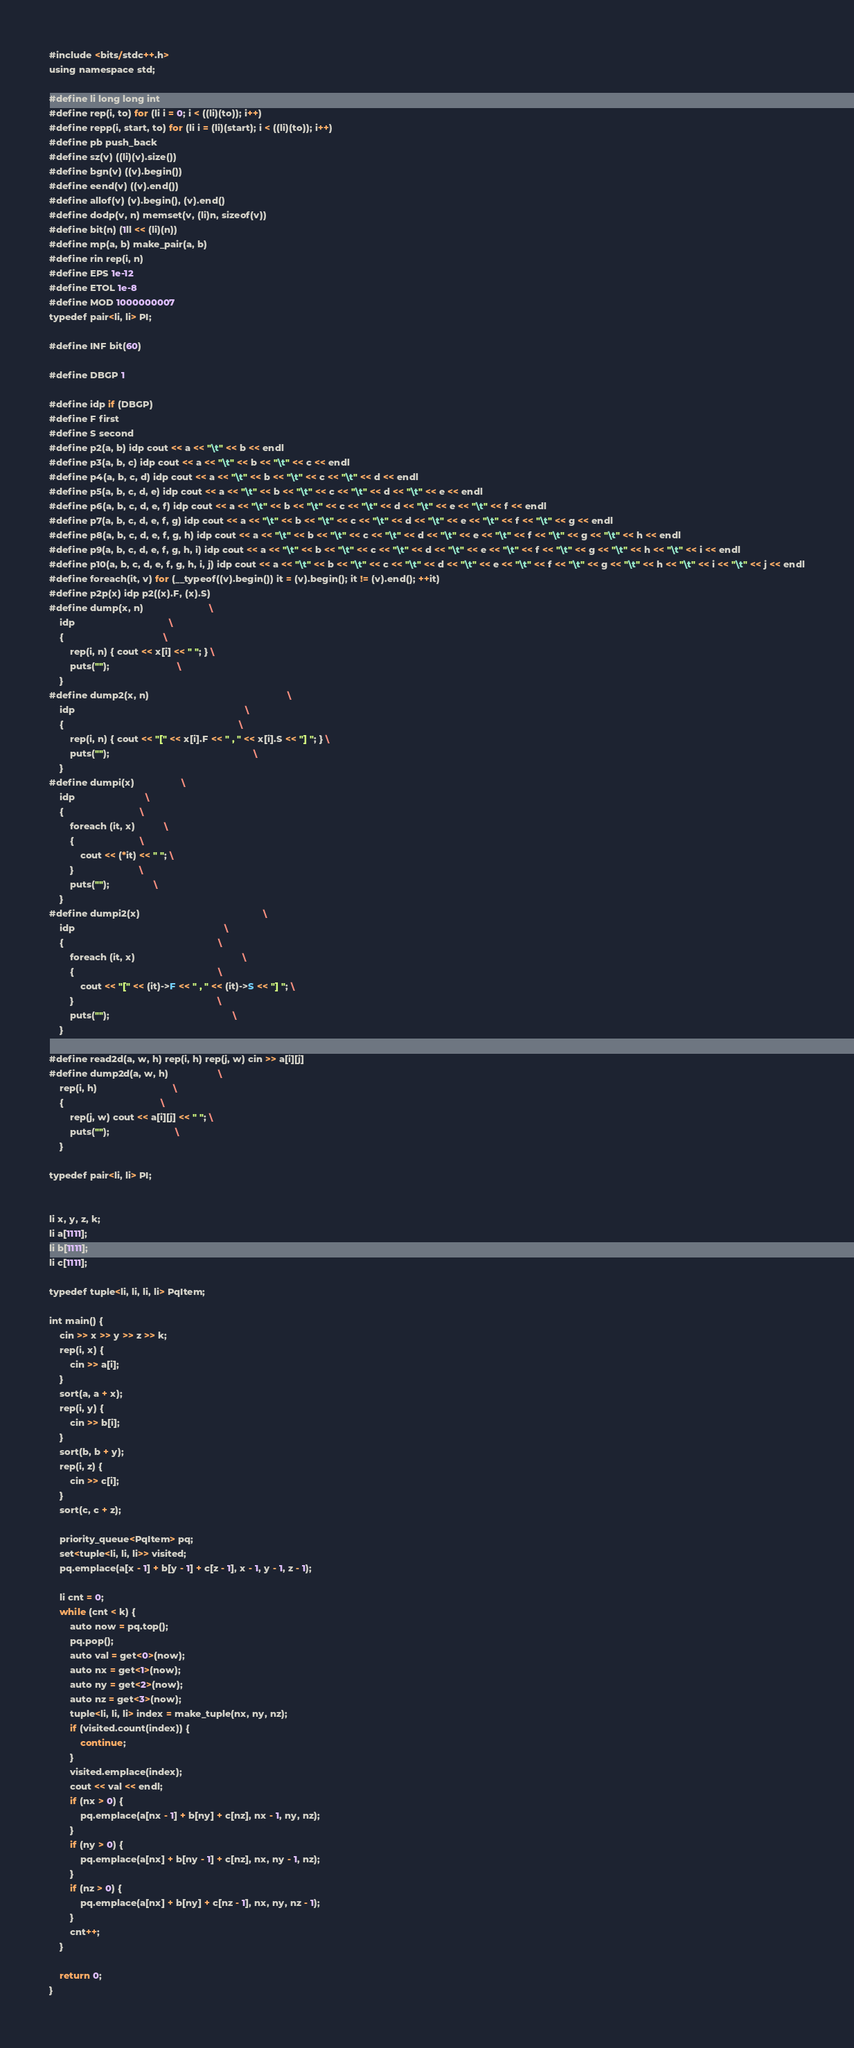<code> <loc_0><loc_0><loc_500><loc_500><_Rust_>#include <bits/stdc++.h>
using namespace std;

#define li long long int
#define rep(i, to) for (li i = 0; i < ((li)(to)); i++)
#define repp(i, start, to) for (li i = (li)(start); i < ((li)(to)); i++)
#define pb push_back
#define sz(v) ((li)(v).size())
#define bgn(v) ((v).begin())
#define eend(v) ((v).end())
#define allof(v) (v).begin(), (v).end()
#define dodp(v, n) memset(v, (li)n, sizeof(v))
#define bit(n) (1ll << (li)(n))
#define mp(a, b) make_pair(a, b)
#define rin rep(i, n)
#define EPS 1e-12
#define ETOL 1e-8
#define MOD 1000000007
typedef pair<li, li> PI;

#define INF bit(60)

#define DBGP 1

#define idp if (DBGP)
#define F first
#define S second
#define p2(a, b) idp cout << a << "\t" << b << endl
#define p3(a, b, c) idp cout << a << "\t" << b << "\t" << c << endl
#define p4(a, b, c, d) idp cout << a << "\t" << b << "\t" << c << "\t" << d << endl
#define p5(a, b, c, d, e) idp cout << a << "\t" << b << "\t" << c << "\t" << d << "\t" << e << endl
#define p6(a, b, c, d, e, f) idp cout << a << "\t" << b << "\t" << c << "\t" << d << "\t" << e << "\t" << f << endl
#define p7(a, b, c, d, e, f, g) idp cout << a << "\t" << b << "\t" << c << "\t" << d << "\t" << e << "\t" << f << "\t" << g << endl
#define p8(a, b, c, d, e, f, g, h) idp cout << a << "\t" << b << "\t" << c << "\t" << d << "\t" << e << "\t" << f << "\t" << g << "\t" << h << endl
#define p9(a, b, c, d, e, f, g, h, i) idp cout << a << "\t" << b << "\t" << c << "\t" << d << "\t" << e << "\t" << f << "\t" << g << "\t" << h << "\t" << i << endl
#define p10(a, b, c, d, e, f, g, h, i, j) idp cout << a << "\t" << b << "\t" << c << "\t" << d << "\t" << e << "\t" << f << "\t" << g << "\t" << h << "\t" << i << "\t" << j << endl
#define foreach(it, v) for (__typeof((v).begin()) it = (v).begin(); it != (v).end(); ++it)
#define p2p(x) idp p2((x).F, (x).S)
#define dump(x, n)                         \
    idp                                    \
    {                                      \
        rep(i, n) { cout << x[i] << " "; } \
        puts("");                          \
    }
#define dump2(x, n)                                                     \
    idp                                                                 \
    {                                                                   \
        rep(i, n) { cout << "[" << x[i].F << " , " << x[i].S << "] "; } \
        puts("");                                                       \
    }
#define dumpi(x)                  \
    idp                           \
    {                             \
        foreach (it, x)           \
        {                         \
            cout << (*it) << " "; \
        }                         \
        puts("");                 \
    }
#define dumpi2(x)                                               \
    idp                                                         \
    {                                                           \
        foreach (it, x)                                         \
        {                                                       \
            cout << "[" << (it)->F << " , " << (it)->S << "] "; \
        }                                                       \
        puts("");                                               \
    }

#define read2d(a, w, h) rep(i, h) rep(j, w) cin >> a[i][j]
#define dump2d(a, w, h)                   \
    rep(i, h)                             \
    {                                     \
        rep(j, w) cout << a[i][j] << " "; \
        puts("");                         \
    }

typedef pair<li, li> PI;


li x, y, z, k;
li a[1111];
li b[1111];
li c[1111];

typedef tuple<li, li, li, li> PqItem;

int main() {
    cin >> x >> y >> z >> k;
    rep(i, x) {
        cin >> a[i];
    }
    sort(a, a + x);
    rep(i, y) {
        cin >> b[i];
    }
    sort(b, b + y);
    rep(i, z) {
        cin >> c[i];
    }
    sort(c, c + z);

    priority_queue<PqItem> pq;
    set<tuple<li, li, li>> visited;
    pq.emplace(a[x - 1] + b[y - 1] + c[z - 1], x - 1, y - 1, z - 1);

    li cnt = 0;
    while (cnt < k) {
        auto now = pq.top();
        pq.pop();
        auto val = get<0>(now);
        auto nx = get<1>(now);
        auto ny = get<2>(now);
        auto nz = get<3>(now);
        tuple<li, li, li> index = make_tuple(nx, ny, nz);
        if (visited.count(index)) {
            continue;
        }
        visited.emplace(index);
        cout << val << endl;
        if (nx > 0) {
            pq.emplace(a[nx - 1] + b[ny] + c[nz], nx - 1, ny, nz);
        }
        if (ny > 0) {
            pq.emplace(a[nx] + b[ny - 1] + c[nz], nx, ny - 1, nz);
        }
        if (nz > 0) {
            pq.emplace(a[nx] + b[ny] + c[nz - 1], nx, ny, nz - 1);
        }
        cnt++;
    }

    return 0;
}</code> 